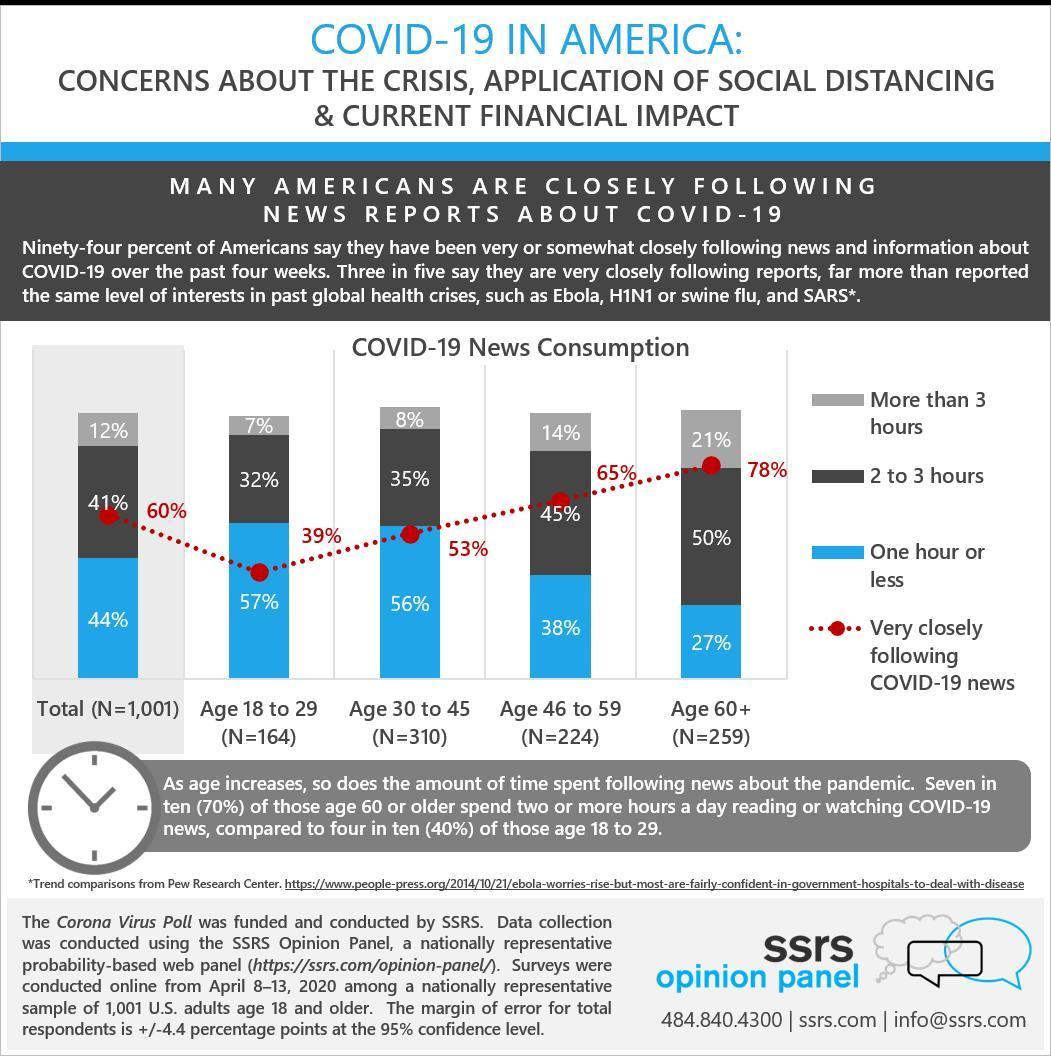How many age groups are the respondents grouped into?
Answer the question with a short phrase. 4 What percent of the senior citizens follow the pandemic news for more than 3 hours daily? 21% What percentage of age 30-45 respondents, follow the news for 2-3 hours daily? 35% Which age group has the least number of respondents? Age 18 to 29 What is the number of respondents in the age group 46-59? 224 How many respondents are there in the age group 18-45? 474 What percent of the total surveyed spend 1 hour or less following the news? 44% What percent of the total surveyed follow the covid-19 news very closely? 60% Which age group has the highest number of respondents? Age 30 to 45 Name 3 viral diseases, other than covid-19, which were closely followed on the news reports? Ebola, H1N1 or swine flu, SARS 